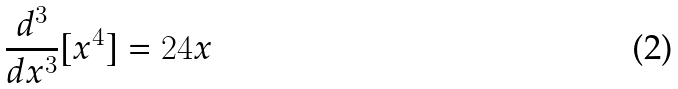<formula> <loc_0><loc_0><loc_500><loc_500>\frac { d ^ { 3 } } { d x ^ { 3 } } [ x ^ { 4 } ] = 2 4 x</formula> 